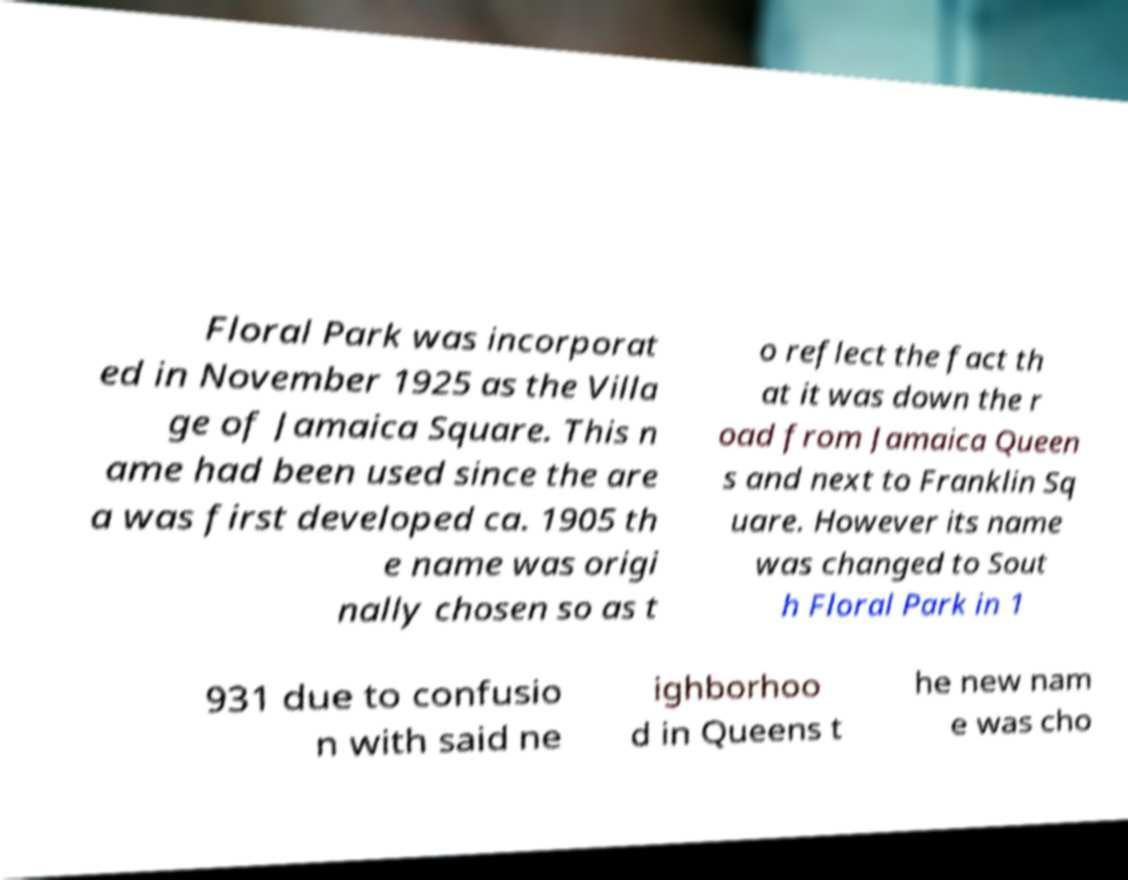Could you assist in decoding the text presented in this image and type it out clearly? Floral Park was incorporat ed in November 1925 as the Villa ge of Jamaica Square. This n ame had been used since the are a was first developed ca. 1905 th e name was origi nally chosen so as t o reflect the fact th at it was down the r oad from Jamaica Queen s and next to Franklin Sq uare. However its name was changed to Sout h Floral Park in 1 931 due to confusio n with said ne ighborhoo d in Queens t he new nam e was cho 